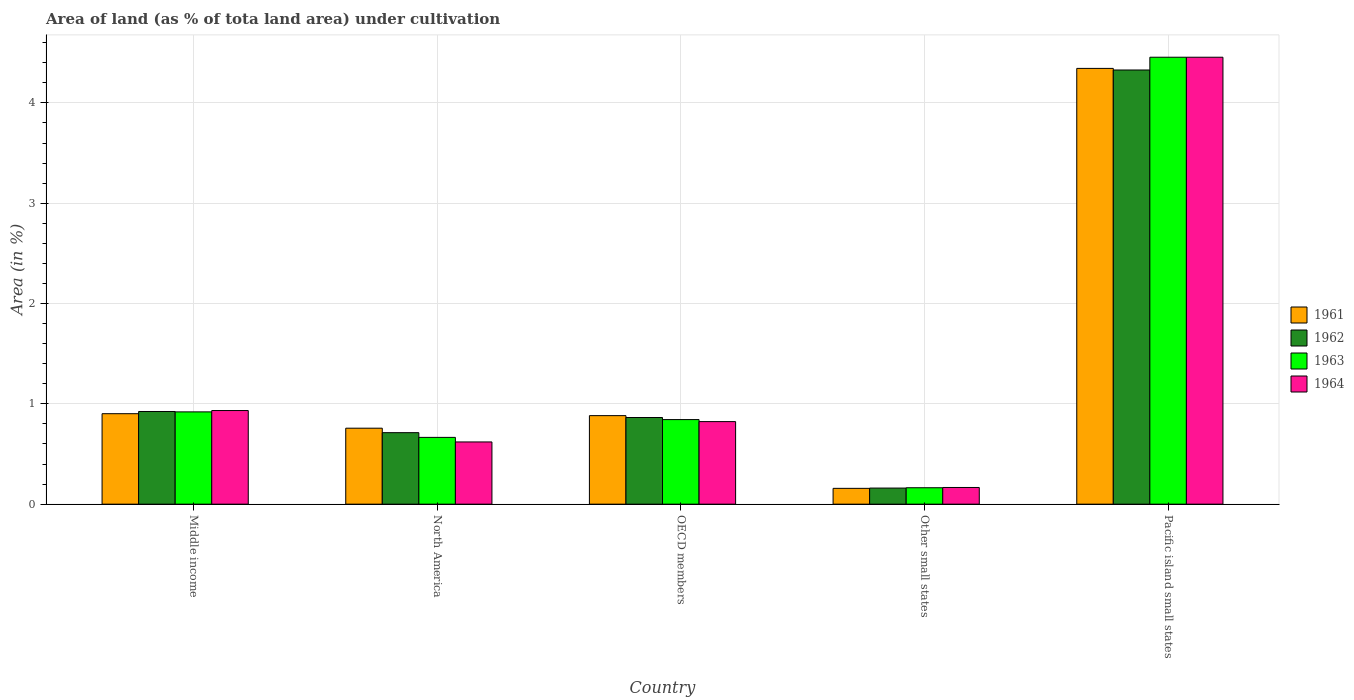How many groups of bars are there?
Offer a very short reply. 5. Are the number of bars per tick equal to the number of legend labels?
Offer a very short reply. Yes. How many bars are there on the 5th tick from the left?
Keep it short and to the point. 4. What is the label of the 2nd group of bars from the left?
Make the answer very short. North America. What is the percentage of land under cultivation in 1964 in Middle income?
Offer a terse response. 0.93. Across all countries, what is the maximum percentage of land under cultivation in 1962?
Your answer should be very brief. 4.33. Across all countries, what is the minimum percentage of land under cultivation in 1964?
Your answer should be compact. 0.17. In which country was the percentage of land under cultivation in 1962 maximum?
Keep it short and to the point. Pacific island small states. In which country was the percentage of land under cultivation in 1961 minimum?
Provide a short and direct response. Other small states. What is the total percentage of land under cultivation in 1963 in the graph?
Offer a very short reply. 7.05. What is the difference between the percentage of land under cultivation in 1963 in Other small states and that in Pacific island small states?
Provide a short and direct response. -4.29. What is the difference between the percentage of land under cultivation in 1961 in OECD members and the percentage of land under cultivation in 1962 in Other small states?
Your answer should be very brief. 0.72. What is the average percentage of land under cultivation in 1964 per country?
Provide a short and direct response. 1.4. What is the difference between the percentage of land under cultivation of/in 1962 and percentage of land under cultivation of/in 1961 in Other small states?
Your answer should be compact. 0. What is the ratio of the percentage of land under cultivation in 1961 in North America to that in OECD members?
Give a very brief answer. 0.86. What is the difference between the highest and the second highest percentage of land under cultivation in 1961?
Keep it short and to the point. 0.02. What is the difference between the highest and the lowest percentage of land under cultivation in 1964?
Ensure brevity in your answer.  4.29. Is the sum of the percentage of land under cultivation in 1964 in Other small states and Pacific island small states greater than the maximum percentage of land under cultivation in 1963 across all countries?
Give a very brief answer. Yes. What does the 2nd bar from the right in Pacific island small states represents?
Your answer should be very brief. 1963. Is it the case that in every country, the sum of the percentage of land under cultivation in 1961 and percentage of land under cultivation in 1963 is greater than the percentage of land under cultivation in 1962?
Provide a short and direct response. Yes. How many countries are there in the graph?
Your response must be concise. 5. What is the difference between two consecutive major ticks on the Y-axis?
Make the answer very short. 1. Where does the legend appear in the graph?
Your answer should be very brief. Center right. How many legend labels are there?
Offer a very short reply. 4. What is the title of the graph?
Keep it short and to the point. Area of land (as % of tota land area) under cultivation. Does "2010" appear as one of the legend labels in the graph?
Offer a very short reply. No. What is the label or title of the X-axis?
Provide a succinct answer. Country. What is the label or title of the Y-axis?
Your answer should be very brief. Area (in %). What is the Area (in %) of 1961 in Middle income?
Ensure brevity in your answer.  0.9. What is the Area (in %) in 1962 in Middle income?
Keep it short and to the point. 0.92. What is the Area (in %) in 1963 in Middle income?
Keep it short and to the point. 0.92. What is the Area (in %) in 1964 in Middle income?
Offer a terse response. 0.93. What is the Area (in %) in 1961 in North America?
Keep it short and to the point. 0.76. What is the Area (in %) in 1962 in North America?
Ensure brevity in your answer.  0.71. What is the Area (in %) in 1963 in North America?
Keep it short and to the point. 0.67. What is the Area (in %) in 1964 in North America?
Make the answer very short. 0.62. What is the Area (in %) of 1961 in OECD members?
Provide a succinct answer. 0.88. What is the Area (in %) of 1962 in OECD members?
Your answer should be very brief. 0.86. What is the Area (in %) in 1963 in OECD members?
Keep it short and to the point. 0.84. What is the Area (in %) of 1964 in OECD members?
Make the answer very short. 0.82. What is the Area (in %) in 1961 in Other small states?
Provide a short and direct response. 0.16. What is the Area (in %) in 1962 in Other small states?
Ensure brevity in your answer.  0.16. What is the Area (in %) of 1963 in Other small states?
Offer a terse response. 0.16. What is the Area (in %) of 1964 in Other small states?
Your answer should be very brief. 0.17. What is the Area (in %) in 1961 in Pacific island small states?
Keep it short and to the point. 4.34. What is the Area (in %) of 1962 in Pacific island small states?
Ensure brevity in your answer.  4.33. What is the Area (in %) in 1963 in Pacific island small states?
Give a very brief answer. 4.46. What is the Area (in %) of 1964 in Pacific island small states?
Make the answer very short. 4.46. Across all countries, what is the maximum Area (in %) of 1961?
Your answer should be compact. 4.34. Across all countries, what is the maximum Area (in %) of 1962?
Offer a very short reply. 4.33. Across all countries, what is the maximum Area (in %) in 1963?
Your response must be concise. 4.46. Across all countries, what is the maximum Area (in %) in 1964?
Ensure brevity in your answer.  4.46. Across all countries, what is the minimum Area (in %) of 1961?
Offer a very short reply. 0.16. Across all countries, what is the minimum Area (in %) of 1962?
Your answer should be very brief. 0.16. Across all countries, what is the minimum Area (in %) of 1963?
Make the answer very short. 0.16. Across all countries, what is the minimum Area (in %) of 1964?
Your answer should be compact. 0.17. What is the total Area (in %) of 1961 in the graph?
Ensure brevity in your answer.  7.04. What is the total Area (in %) of 1962 in the graph?
Give a very brief answer. 6.99. What is the total Area (in %) in 1963 in the graph?
Make the answer very short. 7.05. What is the total Area (in %) of 1964 in the graph?
Your answer should be very brief. 7. What is the difference between the Area (in %) in 1961 in Middle income and that in North America?
Offer a terse response. 0.14. What is the difference between the Area (in %) of 1962 in Middle income and that in North America?
Offer a terse response. 0.21. What is the difference between the Area (in %) in 1963 in Middle income and that in North America?
Your response must be concise. 0.25. What is the difference between the Area (in %) in 1964 in Middle income and that in North America?
Provide a short and direct response. 0.31. What is the difference between the Area (in %) in 1961 in Middle income and that in OECD members?
Make the answer very short. 0.02. What is the difference between the Area (in %) in 1962 in Middle income and that in OECD members?
Your answer should be very brief. 0.06. What is the difference between the Area (in %) in 1963 in Middle income and that in OECD members?
Your response must be concise. 0.08. What is the difference between the Area (in %) in 1964 in Middle income and that in OECD members?
Provide a succinct answer. 0.11. What is the difference between the Area (in %) of 1961 in Middle income and that in Other small states?
Provide a short and direct response. 0.74. What is the difference between the Area (in %) in 1962 in Middle income and that in Other small states?
Your response must be concise. 0.76. What is the difference between the Area (in %) in 1963 in Middle income and that in Other small states?
Offer a terse response. 0.76. What is the difference between the Area (in %) in 1964 in Middle income and that in Other small states?
Make the answer very short. 0.77. What is the difference between the Area (in %) of 1961 in Middle income and that in Pacific island small states?
Your response must be concise. -3.44. What is the difference between the Area (in %) in 1962 in Middle income and that in Pacific island small states?
Make the answer very short. -3.4. What is the difference between the Area (in %) in 1963 in Middle income and that in Pacific island small states?
Make the answer very short. -3.54. What is the difference between the Area (in %) of 1964 in Middle income and that in Pacific island small states?
Provide a short and direct response. -3.52. What is the difference between the Area (in %) of 1961 in North America and that in OECD members?
Give a very brief answer. -0.13. What is the difference between the Area (in %) of 1962 in North America and that in OECD members?
Your answer should be very brief. -0.15. What is the difference between the Area (in %) in 1963 in North America and that in OECD members?
Ensure brevity in your answer.  -0.18. What is the difference between the Area (in %) of 1964 in North America and that in OECD members?
Your response must be concise. -0.2. What is the difference between the Area (in %) in 1961 in North America and that in Other small states?
Your answer should be compact. 0.6. What is the difference between the Area (in %) of 1962 in North America and that in Other small states?
Offer a very short reply. 0.55. What is the difference between the Area (in %) of 1963 in North America and that in Other small states?
Your answer should be very brief. 0.5. What is the difference between the Area (in %) in 1964 in North America and that in Other small states?
Provide a short and direct response. 0.45. What is the difference between the Area (in %) of 1961 in North America and that in Pacific island small states?
Make the answer very short. -3.59. What is the difference between the Area (in %) of 1962 in North America and that in Pacific island small states?
Offer a very short reply. -3.62. What is the difference between the Area (in %) in 1963 in North America and that in Pacific island small states?
Your answer should be very brief. -3.79. What is the difference between the Area (in %) of 1964 in North America and that in Pacific island small states?
Give a very brief answer. -3.84. What is the difference between the Area (in %) in 1961 in OECD members and that in Other small states?
Your answer should be very brief. 0.72. What is the difference between the Area (in %) in 1962 in OECD members and that in Other small states?
Your response must be concise. 0.7. What is the difference between the Area (in %) in 1963 in OECD members and that in Other small states?
Your answer should be compact. 0.68. What is the difference between the Area (in %) of 1964 in OECD members and that in Other small states?
Provide a succinct answer. 0.66. What is the difference between the Area (in %) in 1961 in OECD members and that in Pacific island small states?
Provide a short and direct response. -3.46. What is the difference between the Area (in %) of 1962 in OECD members and that in Pacific island small states?
Offer a very short reply. -3.46. What is the difference between the Area (in %) in 1963 in OECD members and that in Pacific island small states?
Your answer should be very brief. -3.61. What is the difference between the Area (in %) in 1964 in OECD members and that in Pacific island small states?
Your answer should be very brief. -3.63. What is the difference between the Area (in %) of 1961 in Other small states and that in Pacific island small states?
Offer a terse response. -4.19. What is the difference between the Area (in %) of 1962 in Other small states and that in Pacific island small states?
Your response must be concise. -4.17. What is the difference between the Area (in %) of 1963 in Other small states and that in Pacific island small states?
Your response must be concise. -4.29. What is the difference between the Area (in %) in 1964 in Other small states and that in Pacific island small states?
Provide a succinct answer. -4.29. What is the difference between the Area (in %) in 1961 in Middle income and the Area (in %) in 1962 in North America?
Your answer should be very brief. 0.19. What is the difference between the Area (in %) in 1961 in Middle income and the Area (in %) in 1963 in North America?
Provide a short and direct response. 0.24. What is the difference between the Area (in %) of 1961 in Middle income and the Area (in %) of 1964 in North America?
Offer a terse response. 0.28. What is the difference between the Area (in %) in 1962 in Middle income and the Area (in %) in 1963 in North America?
Provide a short and direct response. 0.26. What is the difference between the Area (in %) in 1962 in Middle income and the Area (in %) in 1964 in North America?
Your answer should be compact. 0.3. What is the difference between the Area (in %) of 1963 in Middle income and the Area (in %) of 1964 in North America?
Keep it short and to the point. 0.3. What is the difference between the Area (in %) of 1961 in Middle income and the Area (in %) of 1962 in OECD members?
Your response must be concise. 0.04. What is the difference between the Area (in %) in 1961 in Middle income and the Area (in %) in 1963 in OECD members?
Keep it short and to the point. 0.06. What is the difference between the Area (in %) of 1961 in Middle income and the Area (in %) of 1964 in OECD members?
Give a very brief answer. 0.08. What is the difference between the Area (in %) of 1962 in Middle income and the Area (in %) of 1963 in OECD members?
Your answer should be compact. 0.08. What is the difference between the Area (in %) of 1962 in Middle income and the Area (in %) of 1964 in OECD members?
Provide a succinct answer. 0.1. What is the difference between the Area (in %) in 1963 in Middle income and the Area (in %) in 1964 in OECD members?
Your answer should be very brief. 0.1. What is the difference between the Area (in %) in 1961 in Middle income and the Area (in %) in 1962 in Other small states?
Provide a short and direct response. 0.74. What is the difference between the Area (in %) of 1961 in Middle income and the Area (in %) of 1963 in Other small states?
Your response must be concise. 0.74. What is the difference between the Area (in %) in 1961 in Middle income and the Area (in %) in 1964 in Other small states?
Keep it short and to the point. 0.74. What is the difference between the Area (in %) of 1962 in Middle income and the Area (in %) of 1963 in Other small states?
Offer a very short reply. 0.76. What is the difference between the Area (in %) of 1962 in Middle income and the Area (in %) of 1964 in Other small states?
Provide a short and direct response. 0.76. What is the difference between the Area (in %) in 1963 in Middle income and the Area (in %) in 1964 in Other small states?
Provide a short and direct response. 0.75. What is the difference between the Area (in %) of 1961 in Middle income and the Area (in %) of 1962 in Pacific island small states?
Your answer should be compact. -3.43. What is the difference between the Area (in %) in 1961 in Middle income and the Area (in %) in 1963 in Pacific island small states?
Ensure brevity in your answer.  -3.55. What is the difference between the Area (in %) of 1961 in Middle income and the Area (in %) of 1964 in Pacific island small states?
Offer a terse response. -3.55. What is the difference between the Area (in %) in 1962 in Middle income and the Area (in %) in 1963 in Pacific island small states?
Offer a very short reply. -3.53. What is the difference between the Area (in %) in 1962 in Middle income and the Area (in %) in 1964 in Pacific island small states?
Ensure brevity in your answer.  -3.53. What is the difference between the Area (in %) of 1963 in Middle income and the Area (in %) of 1964 in Pacific island small states?
Provide a succinct answer. -3.54. What is the difference between the Area (in %) of 1961 in North America and the Area (in %) of 1962 in OECD members?
Make the answer very short. -0.11. What is the difference between the Area (in %) in 1961 in North America and the Area (in %) in 1963 in OECD members?
Make the answer very short. -0.09. What is the difference between the Area (in %) of 1961 in North America and the Area (in %) of 1964 in OECD members?
Make the answer very short. -0.07. What is the difference between the Area (in %) in 1962 in North America and the Area (in %) in 1963 in OECD members?
Ensure brevity in your answer.  -0.13. What is the difference between the Area (in %) of 1962 in North America and the Area (in %) of 1964 in OECD members?
Make the answer very short. -0.11. What is the difference between the Area (in %) of 1963 in North America and the Area (in %) of 1964 in OECD members?
Offer a very short reply. -0.16. What is the difference between the Area (in %) in 1961 in North America and the Area (in %) in 1962 in Other small states?
Ensure brevity in your answer.  0.6. What is the difference between the Area (in %) in 1961 in North America and the Area (in %) in 1963 in Other small states?
Your answer should be very brief. 0.59. What is the difference between the Area (in %) in 1961 in North America and the Area (in %) in 1964 in Other small states?
Your response must be concise. 0.59. What is the difference between the Area (in %) of 1962 in North America and the Area (in %) of 1963 in Other small states?
Provide a succinct answer. 0.55. What is the difference between the Area (in %) of 1962 in North America and the Area (in %) of 1964 in Other small states?
Provide a short and direct response. 0.55. What is the difference between the Area (in %) in 1963 in North America and the Area (in %) in 1964 in Other small states?
Ensure brevity in your answer.  0.5. What is the difference between the Area (in %) in 1961 in North America and the Area (in %) in 1962 in Pacific island small states?
Provide a succinct answer. -3.57. What is the difference between the Area (in %) of 1961 in North America and the Area (in %) of 1963 in Pacific island small states?
Provide a short and direct response. -3.7. What is the difference between the Area (in %) in 1961 in North America and the Area (in %) in 1964 in Pacific island small states?
Offer a very short reply. -3.7. What is the difference between the Area (in %) in 1962 in North America and the Area (in %) in 1963 in Pacific island small states?
Offer a very short reply. -3.74. What is the difference between the Area (in %) in 1962 in North America and the Area (in %) in 1964 in Pacific island small states?
Provide a short and direct response. -3.74. What is the difference between the Area (in %) of 1963 in North America and the Area (in %) of 1964 in Pacific island small states?
Your answer should be compact. -3.79. What is the difference between the Area (in %) in 1961 in OECD members and the Area (in %) in 1962 in Other small states?
Ensure brevity in your answer.  0.72. What is the difference between the Area (in %) in 1961 in OECD members and the Area (in %) in 1963 in Other small states?
Give a very brief answer. 0.72. What is the difference between the Area (in %) in 1961 in OECD members and the Area (in %) in 1964 in Other small states?
Provide a succinct answer. 0.72. What is the difference between the Area (in %) in 1962 in OECD members and the Area (in %) in 1963 in Other small states?
Give a very brief answer. 0.7. What is the difference between the Area (in %) of 1962 in OECD members and the Area (in %) of 1964 in Other small states?
Make the answer very short. 0.7. What is the difference between the Area (in %) of 1963 in OECD members and the Area (in %) of 1964 in Other small states?
Provide a succinct answer. 0.68. What is the difference between the Area (in %) in 1961 in OECD members and the Area (in %) in 1962 in Pacific island small states?
Offer a terse response. -3.45. What is the difference between the Area (in %) of 1961 in OECD members and the Area (in %) of 1963 in Pacific island small states?
Make the answer very short. -3.57. What is the difference between the Area (in %) in 1961 in OECD members and the Area (in %) in 1964 in Pacific island small states?
Provide a short and direct response. -3.57. What is the difference between the Area (in %) of 1962 in OECD members and the Area (in %) of 1963 in Pacific island small states?
Your answer should be compact. -3.59. What is the difference between the Area (in %) in 1962 in OECD members and the Area (in %) in 1964 in Pacific island small states?
Make the answer very short. -3.59. What is the difference between the Area (in %) in 1963 in OECD members and the Area (in %) in 1964 in Pacific island small states?
Offer a very short reply. -3.61. What is the difference between the Area (in %) of 1961 in Other small states and the Area (in %) of 1962 in Pacific island small states?
Provide a succinct answer. -4.17. What is the difference between the Area (in %) of 1961 in Other small states and the Area (in %) of 1963 in Pacific island small states?
Keep it short and to the point. -4.3. What is the difference between the Area (in %) in 1961 in Other small states and the Area (in %) in 1964 in Pacific island small states?
Your answer should be very brief. -4.3. What is the difference between the Area (in %) in 1962 in Other small states and the Area (in %) in 1963 in Pacific island small states?
Provide a succinct answer. -4.3. What is the difference between the Area (in %) in 1962 in Other small states and the Area (in %) in 1964 in Pacific island small states?
Your answer should be compact. -4.3. What is the difference between the Area (in %) of 1963 in Other small states and the Area (in %) of 1964 in Pacific island small states?
Provide a short and direct response. -4.29. What is the average Area (in %) of 1961 per country?
Provide a succinct answer. 1.41. What is the average Area (in %) of 1962 per country?
Provide a short and direct response. 1.4. What is the average Area (in %) in 1963 per country?
Your response must be concise. 1.41. What is the average Area (in %) of 1964 per country?
Ensure brevity in your answer.  1.4. What is the difference between the Area (in %) in 1961 and Area (in %) in 1962 in Middle income?
Your answer should be compact. -0.02. What is the difference between the Area (in %) in 1961 and Area (in %) in 1963 in Middle income?
Provide a succinct answer. -0.02. What is the difference between the Area (in %) in 1961 and Area (in %) in 1964 in Middle income?
Give a very brief answer. -0.03. What is the difference between the Area (in %) in 1962 and Area (in %) in 1963 in Middle income?
Make the answer very short. 0. What is the difference between the Area (in %) in 1962 and Area (in %) in 1964 in Middle income?
Your response must be concise. -0.01. What is the difference between the Area (in %) in 1963 and Area (in %) in 1964 in Middle income?
Your answer should be compact. -0.01. What is the difference between the Area (in %) in 1961 and Area (in %) in 1962 in North America?
Offer a very short reply. 0.04. What is the difference between the Area (in %) of 1961 and Area (in %) of 1963 in North America?
Provide a short and direct response. 0.09. What is the difference between the Area (in %) of 1961 and Area (in %) of 1964 in North America?
Ensure brevity in your answer.  0.14. What is the difference between the Area (in %) of 1962 and Area (in %) of 1963 in North America?
Offer a terse response. 0.05. What is the difference between the Area (in %) in 1962 and Area (in %) in 1964 in North America?
Make the answer very short. 0.09. What is the difference between the Area (in %) in 1963 and Area (in %) in 1964 in North America?
Provide a succinct answer. 0.05. What is the difference between the Area (in %) in 1961 and Area (in %) in 1962 in OECD members?
Offer a terse response. 0.02. What is the difference between the Area (in %) in 1961 and Area (in %) in 1963 in OECD members?
Ensure brevity in your answer.  0.04. What is the difference between the Area (in %) of 1961 and Area (in %) of 1964 in OECD members?
Offer a terse response. 0.06. What is the difference between the Area (in %) in 1962 and Area (in %) in 1963 in OECD members?
Make the answer very short. 0.02. What is the difference between the Area (in %) in 1962 and Area (in %) in 1964 in OECD members?
Ensure brevity in your answer.  0.04. What is the difference between the Area (in %) in 1963 and Area (in %) in 1964 in OECD members?
Make the answer very short. 0.02. What is the difference between the Area (in %) of 1961 and Area (in %) of 1962 in Other small states?
Give a very brief answer. -0. What is the difference between the Area (in %) in 1961 and Area (in %) in 1963 in Other small states?
Keep it short and to the point. -0.01. What is the difference between the Area (in %) of 1961 and Area (in %) of 1964 in Other small states?
Provide a succinct answer. -0.01. What is the difference between the Area (in %) in 1962 and Area (in %) in 1963 in Other small states?
Your answer should be very brief. -0. What is the difference between the Area (in %) of 1962 and Area (in %) of 1964 in Other small states?
Offer a terse response. -0.01. What is the difference between the Area (in %) of 1963 and Area (in %) of 1964 in Other small states?
Give a very brief answer. -0. What is the difference between the Area (in %) in 1961 and Area (in %) in 1962 in Pacific island small states?
Provide a short and direct response. 0.02. What is the difference between the Area (in %) of 1961 and Area (in %) of 1963 in Pacific island small states?
Give a very brief answer. -0.11. What is the difference between the Area (in %) in 1961 and Area (in %) in 1964 in Pacific island small states?
Ensure brevity in your answer.  -0.11. What is the difference between the Area (in %) in 1962 and Area (in %) in 1963 in Pacific island small states?
Give a very brief answer. -0.13. What is the difference between the Area (in %) of 1962 and Area (in %) of 1964 in Pacific island small states?
Provide a short and direct response. -0.13. What is the difference between the Area (in %) in 1963 and Area (in %) in 1964 in Pacific island small states?
Make the answer very short. 0. What is the ratio of the Area (in %) of 1961 in Middle income to that in North America?
Your answer should be compact. 1.19. What is the ratio of the Area (in %) in 1962 in Middle income to that in North America?
Offer a very short reply. 1.3. What is the ratio of the Area (in %) in 1963 in Middle income to that in North America?
Your answer should be compact. 1.38. What is the ratio of the Area (in %) in 1964 in Middle income to that in North America?
Make the answer very short. 1.5. What is the ratio of the Area (in %) in 1962 in Middle income to that in OECD members?
Your answer should be compact. 1.07. What is the ratio of the Area (in %) in 1963 in Middle income to that in OECD members?
Provide a short and direct response. 1.09. What is the ratio of the Area (in %) of 1964 in Middle income to that in OECD members?
Your response must be concise. 1.13. What is the ratio of the Area (in %) in 1961 in Middle income to that in Other small states?
Provide a succinct answer. 5.72. What is the ratio of the Area (in %) in 1962 in Middle income to that in Other small states?
Provide a succinct answer. 5.76. What is the ratio of the Area (in %) of 1963 in Middle income to that in Other small states?
Your response must be concise. 5.62. What is the ratio of the Area (in %) of 1964 in Middle income to that in Other small states?
Your answer should be compact. 5.61. What is the ratio of the Area (in %) in 1961 in Middle income to that in Pacific island small states?
Keep it short and to the point. 0.21. What is the ratio of the Area (in %) of 1962 in Middle income to that in Pacific island small states?
Provide a succinct answer. 0.21. What is the ratio of the Area (in %) of 1963 in Middle income to that in Pacific island small states?
Provide a short and direct response. 0.21. What is the ratio of the Area (in %) of 1964 in Middle income to that in Pacific island small states?
Provide a short and direct response. 0.21. What is the ratio of the Area (in %) of 1961 in North America to that in OECD members?
Your answer should be very brief. 0.86. What is the ratio of the Area (in %) in 1962 in North America to that in OECD members?
Provide a short and direct response. 0.83. What is the ratio of the Area (in %) in 1963 in North America to that in OECD members?
Provide a succinct answer. 0.79. What is the ratio of the Area (in %) in 1964 in North America to that in OECD members?
Provide a short and direct response. 0.75. What is the ratio of the Area (in %) of 1961 in North America to that in Other small states?
Your response must be concise. 4.8. What is the ratio of the Area (in %) of 1962 in North America to that in Other small states?
Provide a short and direct response. 4.44. What is the ratio of the Area (in %) in 1963 in North America to that in Other small states?
Your answer should be very brief. 4.07. What is the ratio of the Area (in %) of 1964 in North America to that in Other small states?
Offer a terse response. 3.73. What is the ratio of the Area (in %) of 1961 in North America to that in Pacific island small states?
Ensure brevity in your answer.  0.17. What is the ratio of the Area (in %) in 1962 in North America to that in Pacific island small states?
Offer a terse response. 0.16. What is the ratio of the Area (in %) in 1963 in North America to that in Pacific island small states?
Ensure brevity in your answer.  0.15. What is the ratio of the Area (in %) in 1964 in North America to that in Pacific island small states?
Offer a very short reply. 0.14. What is the ratio of the Area (in %) in 1961 in OECD members to that in Other small states?
Your response must be concise. 5.6. What is the ratio of the Area (in %) in 1962 in OECD members to that in Other small states?
Offer a very short reply. 5.39. What is the ratio of the Area (in %) of 1963 in OECD members to that in Other small states?
Provide a short and direct response. 5.15. What is the ratio of the Area (in %) of 1964 in OECD members to that in Other small states?
Keep it short and to the point. 4.95. What is the ratio of the Area (in %) in 1961 in OECD members to that in Pacific island small states?
Your answer should be very brief. 0.2. What is the ratio of the Area (in %) of 1962 in OECD members to that in Pacific island small states?
Give a very brief answer. 0.2. What is the ratio of the Area (in %) in 1963 in OECD members to that in Pacific island small states?
Make the answer very short. 0.19. What is the ratio of the Area (in %) in 1964 in OECD members to that in Pacific island small states?
Ensure brevity in your answer.  0.18. What is the ratio of the Area (in %) of 1961 in Other small states to that in Pacific island small states?
Offer a very short reply. 0.04. What is the ratio of the Area (in %) of 1962 in Other small states to that in Pacific island small states?
Make the answer very short. 0.04. What is the ratio of the Area (in %) of 1963 in Other small states to that in Pacific island small states?
Provide a short and direct response. 0.04. What is the ratio of the Area (in %) in 1964 in Other small states to that in Pacific island small states?
Provide a short and direct response. 0.04. What is the difference between the highest and the second highest Area (in %) in 1961?
Give a very brief answer. 3.44. What is the difference between the highest and the second highest Area (in %) in 1962?
Ensure brevity in your answer.  3.4. What is the difference between the highest and the second highest Area (in %) in 1963?
Give a very brief answer. 3.54. What is the difference between the highest and the second highest Area (in %) of 1964?
Offer a very short reply. 3.52. What is the difference between the highest and the lowest Area (in %) in 1961?
Your answer should be very brief. 4.19. What is the difference between the highest and the lowest Area (in %) in 1962?
Your answer should be compact. 4.17. What is the difference between the highest and the lowest Area (in %) of 1963?
Keep it short and to the point. 4.29. What is the difference between the highest and the lowest Area (in %) in 1964?
Give a very brief answer. 4.29. 